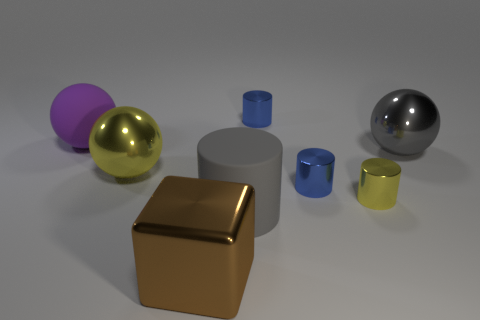There is a sphere that is in front of the large metallic sphere that is on the right side of the big rubber thing that is to the right of the big yellow metal object; what is its size?
Ensure brevity in your answer.  Large. How many things are big yellow shiny balls behind the brown object or big yellow metallic cubes?
Your answer should be very brief. 1. What number of brown cubes are on the left side of the large shiny object that is to the right of the big gray cylinder?
Offer a terse response. 1. Are there more large rubber cylinders that are right of the tiny yellow shiny object than large green shiny cubes?
Ensure brevity in your answer.  No. There is a object that is right of the big brown shiny cube and behind the big gray metallic object; what is its size?
Provide a short and direct response. Small. There is a small thing that is both in front of the purple rubber object and behind the tiny yellow object; what is its shape?
Make the answer very short. Cylinder. There is a blue metal object that is behind the big matte object that is to the left of the brown thing; are there any spheres that are left of it?
Provide a short and direct response. Yes. What number of things are either large things that are on the right side of the big metallic cube or things behind the gray cylinder?
Make the answer very short. 7. Does the yellow thing on the left side of the big brown shiny thing have the same material as the brown thing?
Keep it short and to the point. Yes. There is a ball that is both to the left of the tiny yellow cylinder and to the right of the purple ball; what is its material?
Give a very brief answer. Metal. 